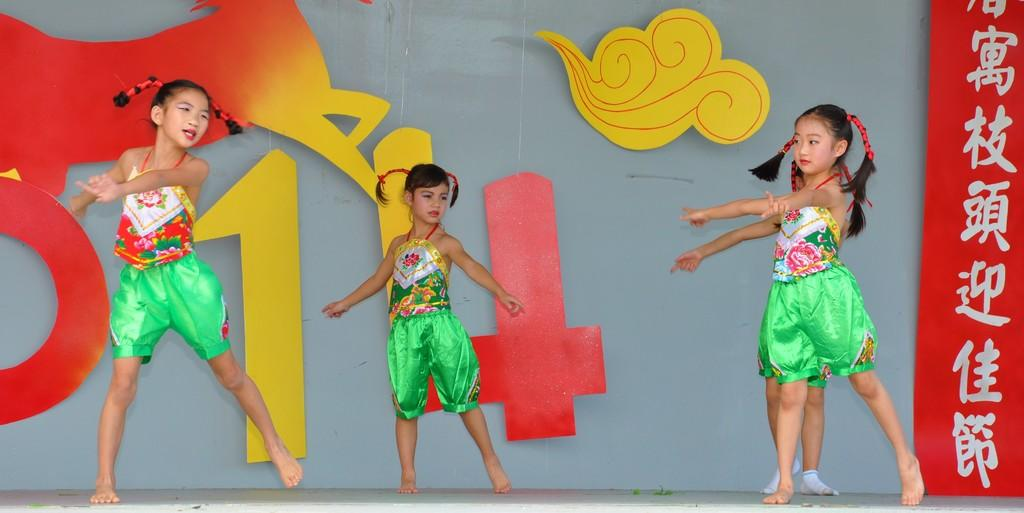How many girls are in the image? There are four girls in the foreground of the image. What are the girls doing in the image? The girls are dancing on the floor. What can be seen on the wall in the background of the image? There are colored chat decorations on the wall in the background. What is present on the right side of the image in the background? There is some text on the right side of the image in the background. Where is the kitten hiding in the image? There is no kitten present in the image. What type of cactus can be seen in the background of the image? There is no cactus present in the image. 